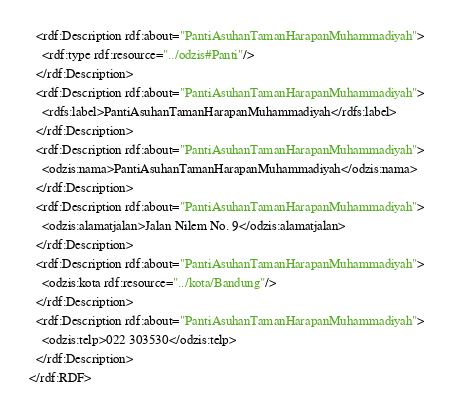<code> <loc_0><loc_0><loc_500><loc_500><_XML_>  <rdf:Description rdf:about="PantiAsuhanTamanHarapanMuhammadiyah">
    <rdf:type rdf:resource="../odzis#Panti"/>
  </rdf:Description>
  <rdf:Description rdf:about="PantiAsuhanTamanHarapanMuhammadiyah">
    <rdfs:label>PantiAsuhanTamanHarapanMuhammadiyah</rdfs:label>
  </rdf:Description>
  <rdf:Description rdf:about="PantiAsuhanTamanHarapanMuhammadiyah">
    <odzis:nama>PantiAsuhanTamanHarapanMuhammadiyah</odzis:nama>
  </rdf:Description>
  <rdf:Description rdf:about="PantiAsuhanTamanHarapanMuhammadiyah">
    <odzis:alamatjalan>Jalan Nilem No. 9</odzis:alamatjalan>
  </rdf:Description>
  <rdf:Description rdf:about="PantiAsuhanTamanHarapanMuhammadiyah">
    <odzis:kota rdf:resource="../kota/Bandung"/>
  </rdf:Description>
  <rdf:Description rdf:about="PantiAsuhanTamanHarapanMuhammadiyah">
    <odzis:telp>022 303530</odzis:telp>
  </rdf:Description>
</rdf:RDF>
</code> 